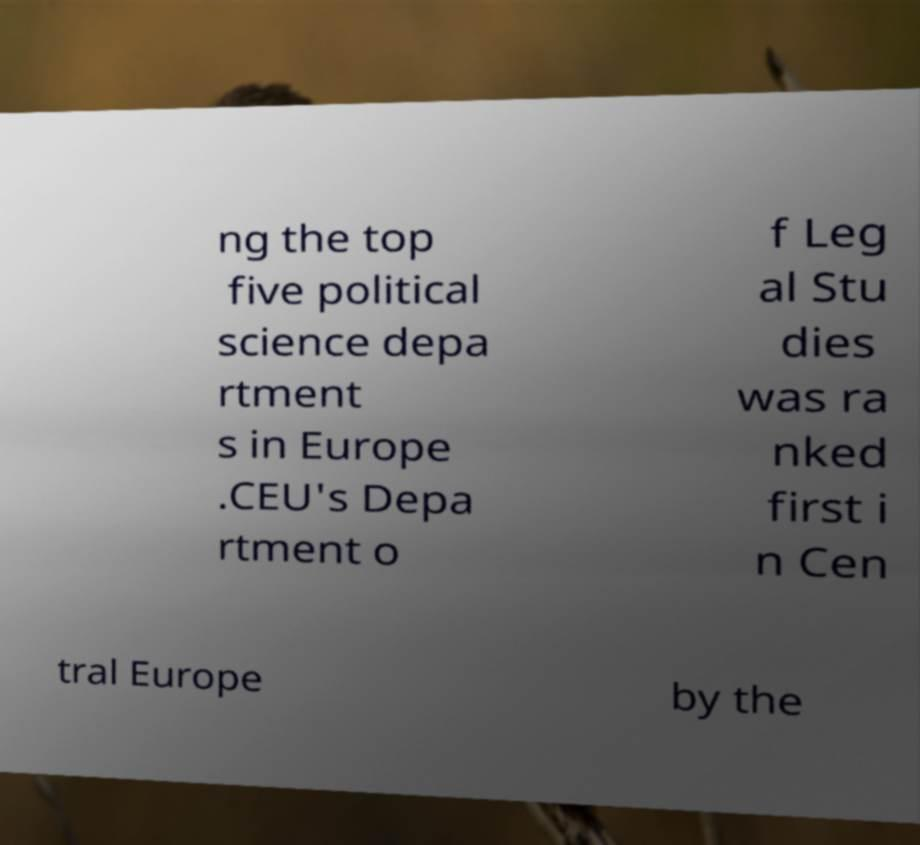I need the written content from this picture converted into text. Can you do that? ng the top five political science depa rtment s in Europe .CEU's Depa rtment o f Leg al Stu dies was ra nked first i n Cen tral Europe by the 